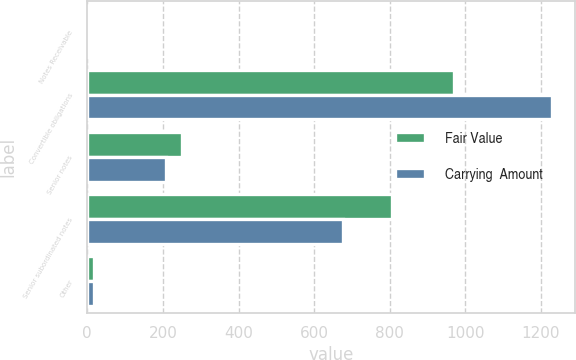<chart> <loc_0><loc_0><loc_500><loc_500><stacked_bar_chart><ecel><fcel>Notes Receivable<fcel>Convertible obligations<fcel>Senior notes<fcel>Senior subordinated notes<fcel>Other<nl><fcel>Fair Value<fcel>2.7<fcel>969.1<fcel>250<fcel>806.3<fcel>18.1<nl><fcel>Carrying  Amount<fcel>2.7<fcel>1227.7<fcel>209.3<fcel>675.9<fcel>18.1<nl></chart> 